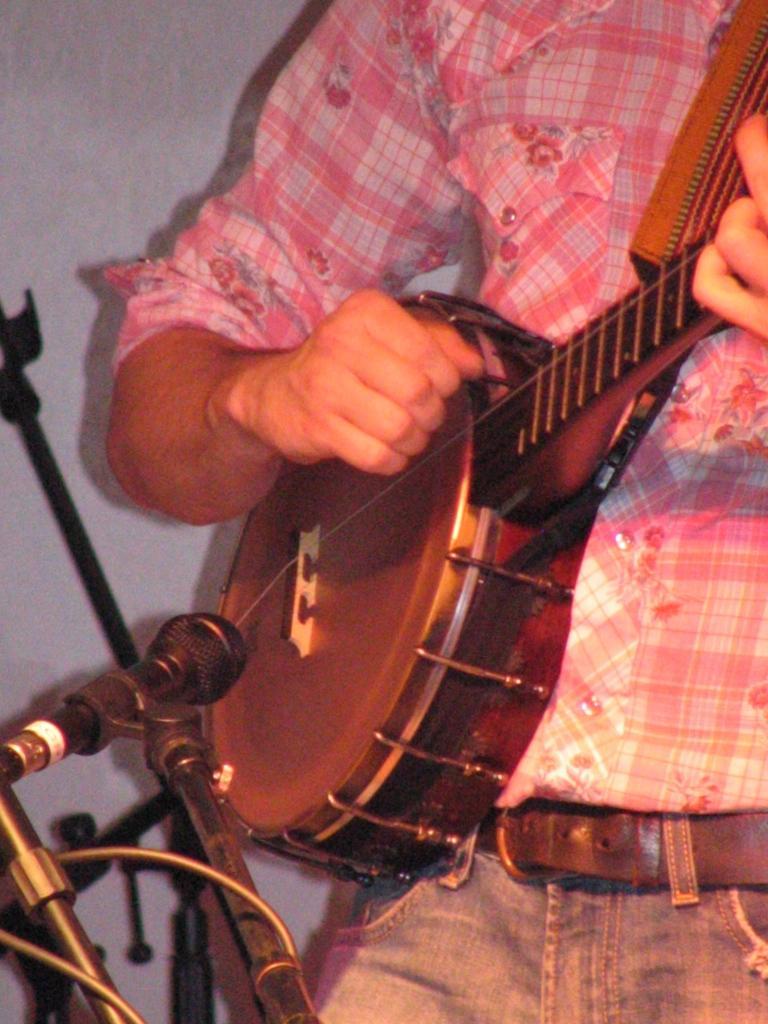Please provide a concise description of this image. In this image I can see a hand of a person and a musical instrument. Here I can see a mic in front of musical instrument. 